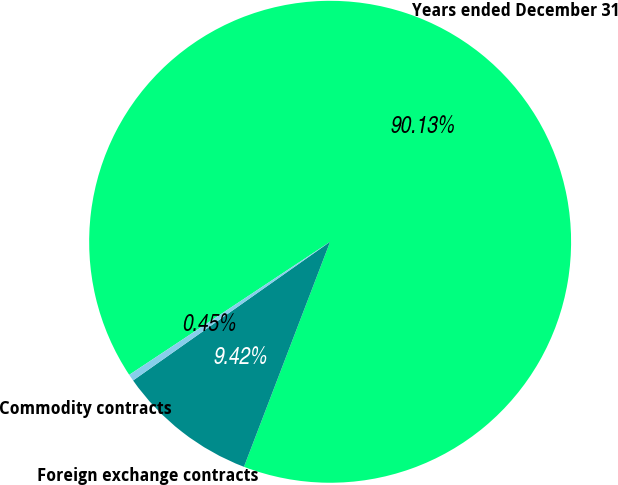<chart> <loc_0><loc_0><loc_500><loc_500><pie_chart><fcel>Years ended December 31<fcel>Foreign exchange contracts<fcel>Commodity contracts<nl><fcel>90.14%<fcel>9.42%<fcel>0.45%<nl></chart> 